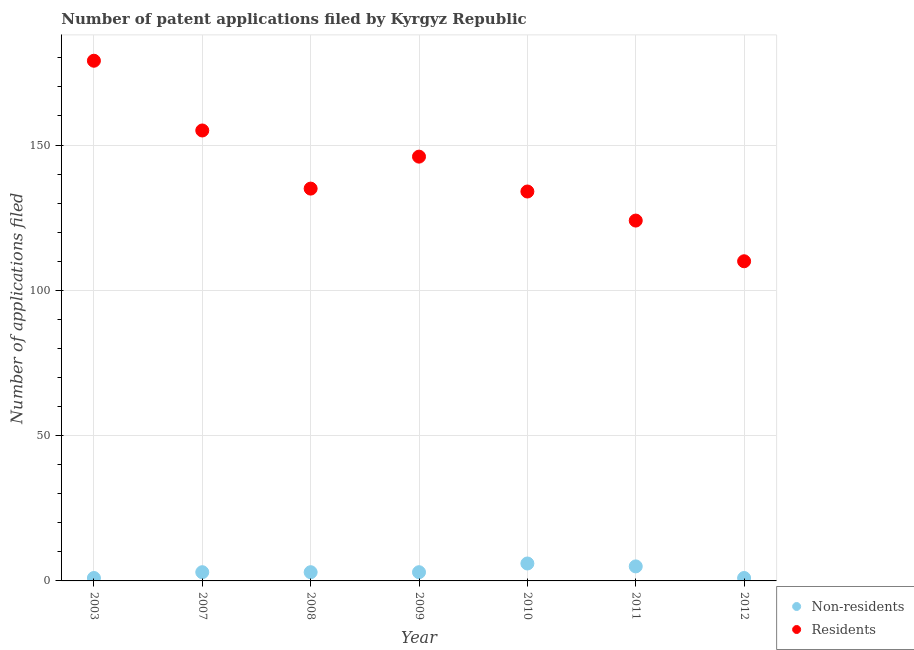How many different coloured dotlines are there?
Your response must be concise. 2. Is the number of dotlines equal to the number of legend labels?
Your answer should be very brief. Yes. What is the number of patent applications by non residents in 2011?
Offer a terse response. 5. Across all years, what is the minimum number of patent applications by residents?
Your answer should be compact. 110. What is the total number of patent applications by non residents in the graph?
Ensure brevity in your answer.  22. What is the difference between the number of patent applications by residents in 2009 and that in 2012?
Offer a very short reply. 36. What is the difference between the number of patent applications by non residents in 2012 and the number of patent applications by residents in 2009?
Offer a terse response. -145. What is the average number of patent applications by residents per year?
Offer a terse response. 140.43. In the year 2007, what is the difference between the number of patent applications by residents and number of patent applications by non residents?
Make the answer very short. 152. What is the ratio of the number of patent applications by residents in 2007 to that in 2008?
Make the answer very short. 1.15. Is the number of patent applications by non residents in 2009 less than that in 2012?
Make the answer very short. No. Is the difference between the number of patent applications by non residents in 2009 and 2010 greater than the difference between the number of patent applications by residents in 2009 and 2010?
Make the answer very short. No. What is the difference between the highest and the lowest number of patent applications by residents?
Your response must be concise. 69. In how many years, is the number of patent applications by residents greater than the average number of patent applications by residents taken over all years?
Offer a terse response. 3. Is the sum of the number of patent applications by residents in 2003 and 2010 greater than the maximum number of patent applications by non residents across all years?
Offer a very short reply. Yes. Is the number of patent applications by non residents strictly greater than the number of patent applications by residents over the years?
Your answer should be very brief. No. Is the number of patent applications by non residents strictly less than the number of patent applications by residents over the years?
Provide a short and direct response. Yes. How many dotlines are there?
Provide a succinct answer. 2. How many years are there in the graph?
Give a very brief answer. 7. Are the values on the major ticks of Y-axis written in scientific E-notation?
Provide a short and direct response. No. Does the graph contain any zero values?
Make the answer very short. No. Does the graph contain grids?
Make the answer very short. Yes. Where does the legend appear in the graph?
Give a very brief answer. Bottom right. How many legend labels are there?
Your answer should be very brief. 2. What is the title of the graph?
Give a very brief answer. Number of patent applications filed by Kyrgyz Republic. What is the label or title of the Y-axis?
Provide a short and direct response. Number of applications filed. What is the Number of applications filed of Residents in 2003?
Your answer should be compact. 179. What is the Number of applications filed in Residents in 2007?
Provide a short and direct response. 155. What is the Number of applications filed of Non-residents in 2008?
Keep it short and to the point. 3. What is the Number of applications filed of Residents in 2008?
Give a very brief answer. 135. What is the Number of applications filed of Residents in 2009?
Offer a terse response. 146. What is the Number of applications filed of Residents in 2010?
Give a very brief answer. 134. What is the Number of applications filed of Residents in 2011?
Make the answer very short. 124. What is the Number of applications filed of Residents in 2012?
Provide a short and direct response. 110. Across all years, what is the maximum Number of applications filed in Non-residents?
Provide a succinct answer. 6. Across all years, what is the maximum Number of applications filed in Residents?
Offer a very short reply. 179. Across all years, what is the minimum Number of applications filed of Residents?
Your answer should be compact. 110. What is the total Number of applications filed of Non-residents in the graph?
Ensure brevity in your answer.  22. What is the total Number of applications filed in Residents in the graph?
Your answer should be compact. 983. What is the difference between the Number of applications filed in Residents in 2003 and that in 2007?
Give a very brief answer. 24. What is the difference between the Number of applications filed of Non-residents in 2003 and that in 2008?
Offer a very short reply. -2. What is the difference between the Number of applications filed in Non-residents in 2003 and that in 2009?
Your answer should be compact. -2. What is the difference between the Number of applications filed of Residents in 2003 and that in 2009?
Your answer should be compact. 33. What is the difference between the Number of applications filed in Non-residents in 2003 and that in 2010?
Provide a short and direct response. -5. What is the difference between the Number of applications filed in Non-residents in 2003 and that in 2011?
Offer a very short reply. -4. What is the difference between the Number of applications filed in Residents in 2003 and that in 2011?
Offer a terse response. 55. What is the difference between the Number of applications filed in Non-residents in 2003 and that in 2012?
Offer a very short reply. 0. What is the difference between the Number of applications filed in Non-residents in 2007 and that in 2009?
Offer a terse response. 0. What is the difference between the Number of applications filed in Residents in 2007 and that in 2009?
Offer a terse response. 9. What is the difference between the Number of applications filed of Non-residents in 2007 and that in 2010?
Your response must be concise. -3. What is the difference between the Number of applications filed in Non-residents in 2007 and that in 2011?
Your response must be concise. -2. What is the difference between the Number of applications filed in Residents in 2007 and that in 2012?
Your response must be concise. 45. What is the difference between the Number of applications filed of Non-residents in 2008 and that in 2009?
Make the answer very short. 0. What is the difference between the Number of applications filed of Residents in 2008 and that in 2009?
Your answer should be very brief. -11. What is the difference between the Number of applications filed of Non-residents in 2008 and that in 2010?
Your response must be concise. -3. What is the difference between the Number of applications filed of Residents in 2008 and that in 2011?
Give a very brief answer. 11. What is the difference between the Number of applications filed in Non-residents in 2008 and that in 2012?
Provide a succinct answer. 2. What is the difference between the Number of applications filed of Residents in 2008 and that in 2012?
Make the answer very short. 25. What is the difference between the Number of applications filed in Non-residents in 2009 and that in 2010?
Provide a succinct answer. -3. What is the difference between the Number of applications filed in Residents in 2009 and that in 2010?
Offer a terse response. 12. What is the difference between the Number of applications filed of Non-residents in 2009 and that in 2011?
Ensure brevity in your answer.  -2. What is the difference between the Number of applications filed of Residents in 2009 and that in 2011?
Offer a terse response. 22. What is the difference between the Number of applications filed in Non-residents in 2009 and that in 2012?
Your answer should be very brief. 2. What is the difference between the Number of applications filed of Residents in 2009 and that in 2012?
Keep it short and to the point. 36. What is the difference between the Number of applications filed of Non-residents in 2010 and that in 2011?
Your answer should be compact. 1. What is the difference between the Number of applications filed of Residents in 2010 and that in 2012?
Give a very brief answer. 24. What is the difference between the Number of applications filed of Non-residents in 2011 and that in 2012?
Keep it short and to the point. 4. What is the difference between the Number of applications filed in Non-residents in 2003 and the Number of applications filed in Residents in 2007?
Your answer should be very brief. -154. What is the difference between the Number of applications filed in Non-residents in 2003 and the Number of applications filed in Residents in 2008?
Keep it short and to the point. -134. What is the difference between the Number of applications filed of Non-residents in 2003 and the Number of applications filed of Residents in 2009?
Your answer should be very brief. -145. What is the difference between the Number of applications filed in Non-residents in 2003 and the Number of applications filed in Residents in 2010?
Your answer should be compact. -133. What is the difference between the Number of applications filed of Non-residents in 2003 and the Number of applications filed of Residents in 2011?
Give a very brief answer. -123. What is the difference between the Number of applications filed of Non-residents in 2003 and the Number of applications filed of Residents in 2012?
Ensure brevity in your answer.  -109. What is the difference between the Number of applications filed of Non-residents in 2007 and the Number of applications filed of Residents in 2008?
Offer a very short reply. -132. What is the difference between the Number of applications filed of Non-residents in 2007 and the Number of applications filed of Residents in 2009?
Give a very brief answer. -143. What is the difference between the Number of applications filed of Non-residents in 2007 and the Number of applications filed of Residents in 2010?
Make the answer very short. -131. What is the difference between the Number of applications filed in Non-residents in 2007 and the Number of applications filed in Residents in 2011?
Keep it short and to the point. -121. What is the difference between the Number of applications filed in Non-residents in 2007 and the Number of applications filed in Residents in 2012?
Provide a short and direct response. -107. What is the difference between the Number of applications filed of Non-residents in 2008 and the Number of applications filed of Residents in 2009?
Give a very brief answer. -143. What is the difference between the Number of applications filed in Non-residents in 2008 and the Number of applications filed in Residents in 2010?
Your response must be concise. -131. What is the difference between the Number of applications filed of Non-residents in 2008 and the Number of applications filed of Residents in 2011?
Ensure brevity in your answer.  -121. What is the difference between the Number of applications filed of Non-residents in 2008 and the Number of applications filed of Residents in 2012?
Make the answer very short. -107. What is the difference between the Number of applications filed in Non-residents in 2009 and the Number of applications filed in Residents in 2010?
Provide a short and direct response. -131. What is the difference between the Number of applications filed in Non-residents in 2009 and the Number of applications filed in Residents in 2011?
Your response must be concise. -121. What is the difference between the Number of applications filed of Non-residents in 2009 and the Number of applications filed of Residents in 2012?
Your response must be concise. -107. What is the difference between the Number of applications filed of Non-residents in 2010 and the Number of applications filed of Residents in 2011?
Your answer should be very brief. -118. What is the difference between the Number of applications filed of Non-residents in 2010 and the Number of applications filed of Residents in 2012?
Make the answer very short. -104. What is the difference between the Number of applications filed in Non-residents in 2011 and the Number of applications filed in Residents in 2012?
Provide a short and direct response. -105. What is the average Number of applications filed in Non-residents per year?
Ensure brevity in your answer.  3.14. What is the average Number of applications filed in Residents per year?
Your response must be concise. 140.43. In the year 2003, what is the difference between the Number of applications filed in Non-residents and Number of applications filed in Residents?
Offer a very short reply. -178. In the year 2007, what is the difference between the Number of applications filed in Non-residents and Number of applications filed in Residents?
Ensure brevity in your answer.  -152. In the year 2008, what is the difference between the Number of applications filed in Non-residents and Number of applications filed in Residents?
Give a very brief answer. -132. In the year 2009, what is the difference between the Number of applications filed in Non-residents and Number of applications filed in Residents?
Keep it short and to the point. -143. In the year 2010, what is the difference between the Number of applications filed in Non-residents and Number of applications filed in Residents?
Provide a short and direct response. -128. In the year 2011, what is the difference between the Number of applications filed in Non-residents and Number of applications filed in Residents?
Your response must be concise. -119. In the year 2012, what is the difference between the Number of applications filed in Non-residents and Number of applications filed in Residents?
Keep it short and to the point. -109. What is the ratio of the Number of applications filed in Non-residents in 2003 to that in 2007?
Ensure brevity in your answer.  0.33. What is the ratio of the Number of applications filed in Residents in 2003 to that in 2007?
Offer a very short reply. 1.15. What is the ratio of the Number of applications filed in Residents in 2003 to that in 2008?
Offer a very short reply. 1.33. What is the ratio of the Number of applications filed in Residents in 2003 to that in 2009?
Provide a short and direct response. 1.23. What is the ratio of the Number of applications filed in Residents in 2003 to that in 2010?
Give a very brief answer. 1.34. What is the ratio of the Number of applications filed in Residents in 2003 to that in 2011?
Your response must be concise. 1.44. What is the ratio of the Number of applications filed of Residents in 2003 to that in 2012?
Make the answer very short. 1.63. What is the ratio of the Number of applications filed of Non-residents in 2007 to that in 2008?
Provide a succinct answer. 1. What is the ratio of the Number of applications filed of Residents in 2007 to that in 2008?
Ensure brevity in your answer.  1.15. What is the ratio of the Number of applications filed of Non-residents in 2007 to that in 2009?
Offer a very short reply. 1. What is the ratio of the Number of applications filed in Residents in 2007 to that in 2009?
Your response must be concise. 1.06. What is the ratio of the Number of applications filed in Residents in 2007 to that in 2010?
Make the answer very short. 1.16. What is the ratio of the Number of applications filed in Residents in 2007 to that in 2011?
Your response must be concise. 1.25. What is the ratio of the Number of applications filed in Non-residents in 2007 to that in 2012?
Provide a succinct answer. 3. What is the ratio of the Number of applications filed in Residents in 2007 to that in 2012?
Your answer should be compact. 1.41. What is the ratio of the Number of applications filed in Residents in 2008 to that in 2009?
Your answer should be very brief. 0.92. What is the ratio of the Number of applications filed of Non-residents in 2008 to that in 2010?
Offer a very short reply. 0.5. What is the ratio of the Number of applications filed in Residents in 2008 to that in 2010?
Make the answer very short. 1.01. What is the ratio of the Number of applications filed of Non-residents in 2008 to that in 2011?
Your answer should be compact. 0.6. What is the ratio of the Number of applications filed in Residents in 2008 to that in 2011?
Provide a succinct answer. 1.09. What is the ratio of the Number of applications filed in Non-residents in 2008 to that in 2012?
Offer a very short reply. 3. What is the ratio of the Number of applications filed of Residents in 2008 to that in 2012?
Your answer should be very brief. 1.23. What is the ratio of the Number of applications filed in Residents in 2009 to that in 2010?
Provide a short and direct response. 1.09. What is the ratio of the Number of applications filed in Residents in 2009 to that in 2011?
Your answer should be compact. 1.18. What is the ratio of the Number of applications filed of Residents in 2009 to that in 2012?
Offer a terse response. 1.33. What is the ratio of the Number of applications filed of Non-residents in 2010 to that in 2011?
Offer a very short reply. 1.2. What is the ratio of the Number of applications filed in Residents in 2010 to that in 2011?
Make the answer very short. 1.08. What is the ratio of the Number of applications filed of Non-residents in 2010 to that in 2012?
Offer a terse response. 6. What is the ratio of the Number of applications filed in Residents in 2010 to that in 2012?
Ensure brevity in your answer.  1.22. What is the ratio of the Number of applications filed in Residents in 2011 to that in 2012?
Your response must be concise. 1.13. What is the difference between the highest and the second highest Number of applications filed in Residents?
Your response must be concise. 24. 